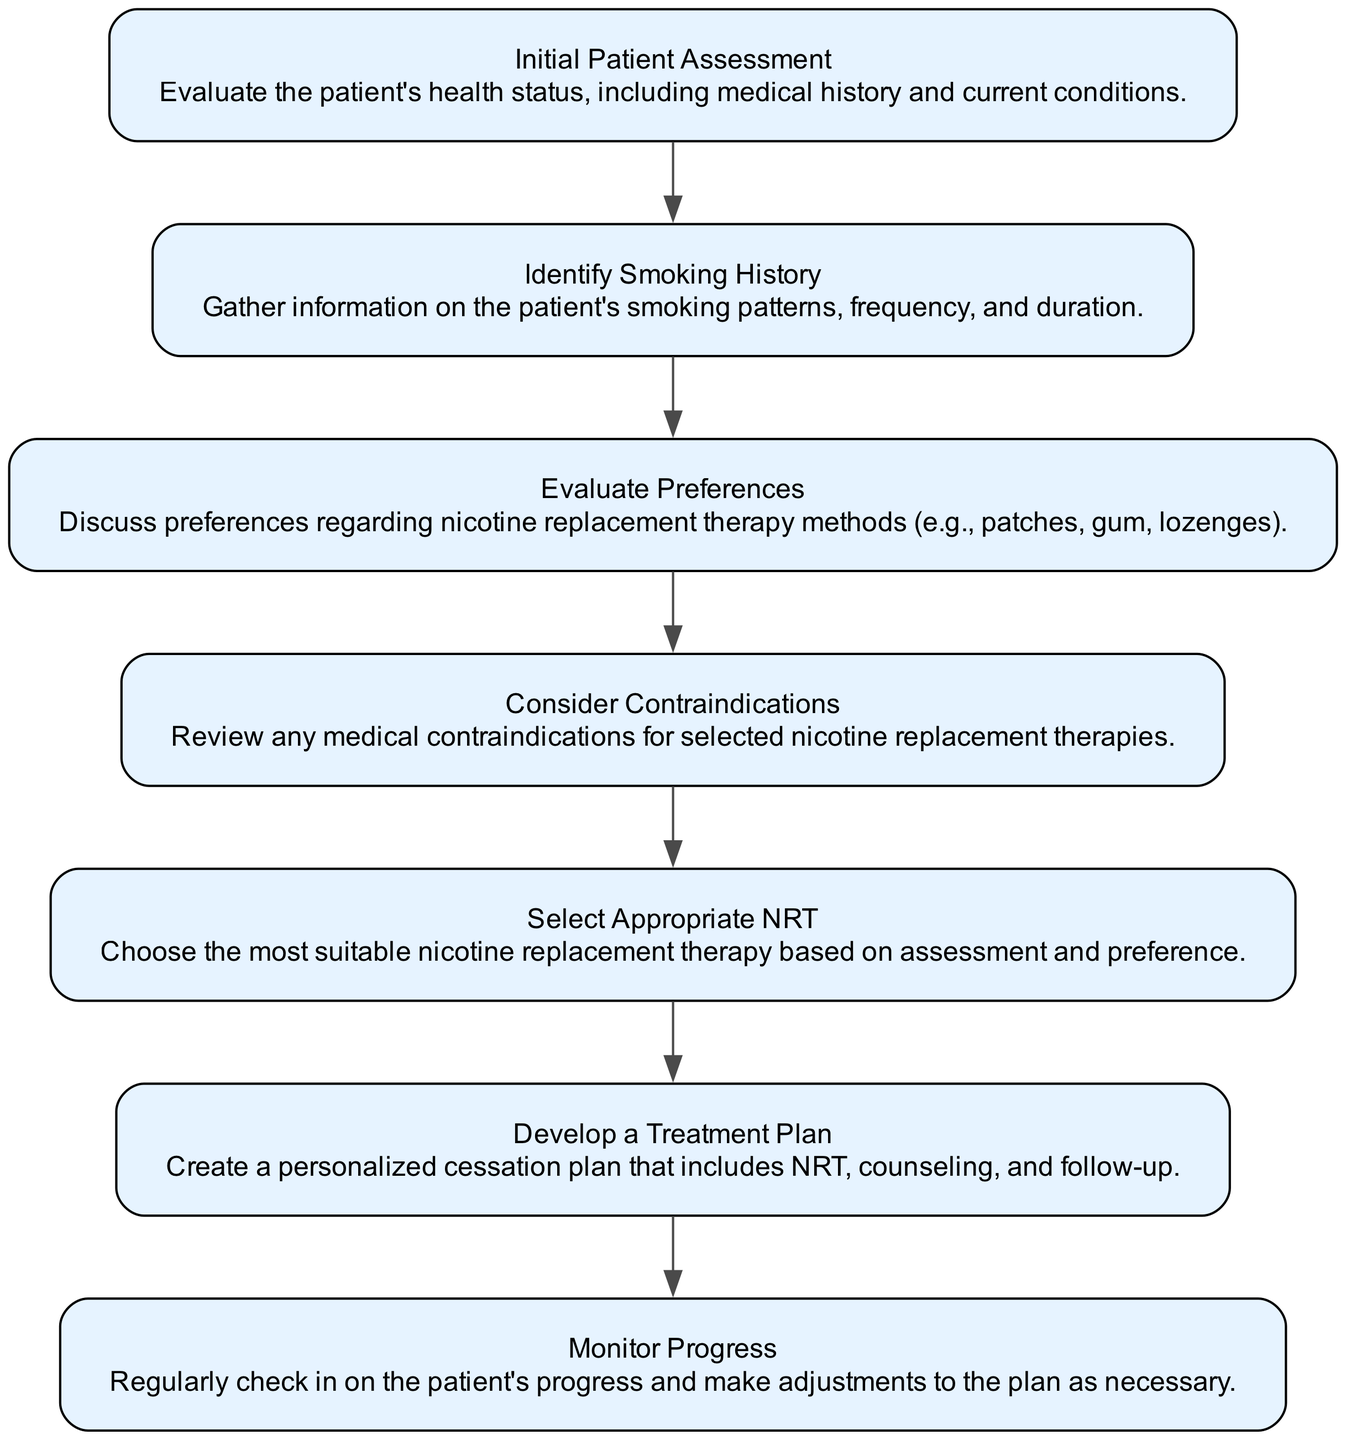What is the first step in the flow chart? The first step in the flow chart is "Initial Patient Assessment," as it is the first node outlined in the diagram.
Answer: Initial Patient Assessment How many nodes are in the diagram? The diagram contains a total of seven nodes, each representing a different step in the decision-making process.
Answer: 7 What node follows "Identify Smoking History"? The node that follows "Identify Smoking History" is "Evaluate Preferences," as it is the next step in the flow after evaluating the smoking history.
Answer: Evaluate Preferences What is the description of the "Select Appropriate NRT" node? The description of the "Select Appropriate NRT" node is "Choose the most suitable nicotine replacement therapy based on assessment and preference." This is the direct text found in the diagram for that node.
Answer: Choose the most suitable nicotine replacement therapy based on assessment and preference Which nodes require considering contraindications? The "Consider Contraindications" node explicitly requires reviewing any medical contraindications before moving on to select the appropriate nicotine replacement therapy.
Answer: Consider Contraindications Which two nodes lead to the "Develop a Treatment Plan"? The "Select Appropriate NRT" node leads to the "Develop a Treatment Plan" node. This is a one-step flow from the selection to the planning phase.
Answer: Select Appropriate NRT What action follows "Monitor Progress"? There is no specific action following "Monitor Progress" in this flow chart, as it is the last step indicating an ongoing process of monitoring.
Answer: None After evaluating preferences, what should be done next? After evaluating preferences, the next step is to "Consider Contraindications," as per the sequence illustrated in the flow chart.
Answer: Consider Contraindications 